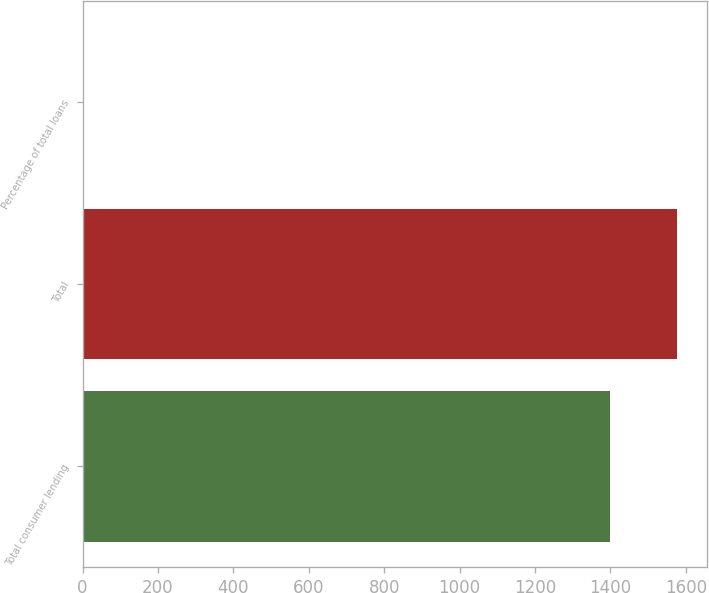Convert chart. <chart><loc_0><loc_0><loc_500><loc_500><bar_chart><fcel>Total consumer lending<fcel>Total<fcel>Percentage of total loans<nl><fcel>1399<fcel>1576<fcel>0.75<nl></chart> 